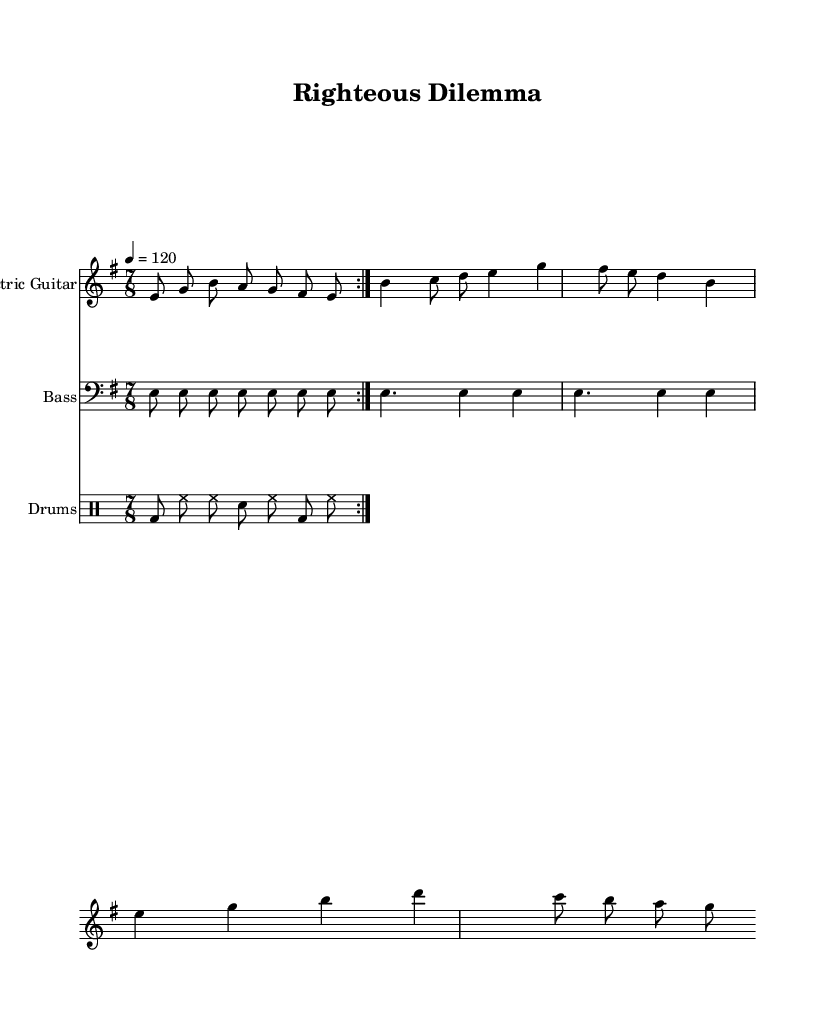What is the key signature of this composition? The key signature is indicated by the 'e' in the global settings of the music, which means it has one sharp, F#.
Answer: E minor What is the time signature used in this piece? The time signature is specified as 7/8 in the global settings, indicating that there are seven eighth notes per measure.
Answer: 7/8 What is the tempo marking for this composition? The tempo is indicated as 4 = 120 in the global section, which means every quarter note equals 120 beats per minute.
Answer: 120 How many times is the main riff repeated? The music indicates a repeat of the main riff twice, as shown by 'volta 2' in the electric guitar part.
Answer: 2 What type of drum pattern is utilized in this composition? The drum pattern is described as featuring a kick drum (bd), hi-hat (hh), and snare drum (sn), which is typical in metal genres emphasizing aggressive rhythm.
Answer: Basic metal pattern What is the primary theme addressed in "Righteous Dilemma"? The title suggests an exploration of moral and ethical dilemmas, which reflects common themes in progressive metal lyrics, often prompting listeners to reflect on deeper issues.
Answer: Moral dilemmas What is the style of the electric guitar melody in this piece? The electric guitar melody features a mixture of single-note lines and chord-like structures, which is characteristic of progressive metal often combining complexity and melody.
Answer: Progressive metal 